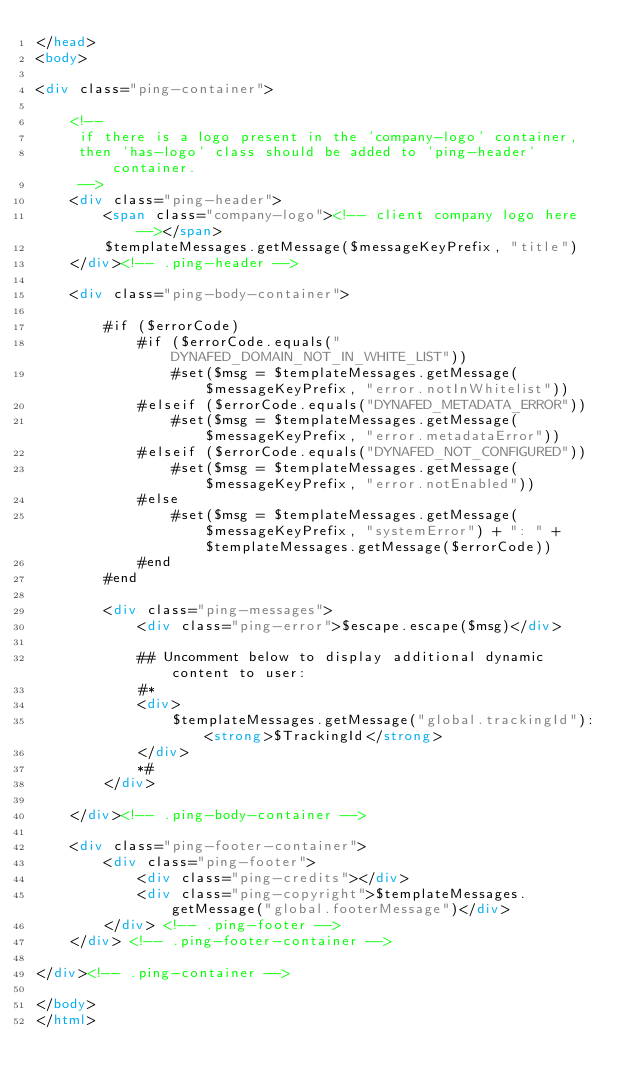Convert code to text. <code><loc_0><loc_0><loc_500><loc_500><_HTML_></head>
<body>
    
<div class="ping-container">
    
    <!-- 
     if there is a logo present in the 'company-logo' container,
     then 'has-logo' class should be added to 'ping-header' container.
     -->
    <div class="ping-header">
        <span class="company-logo"><!-- client company logo here --></span>
        $templateMessages.getMessage($messageKeyPrefix, "title")
    </div><!-- .ping-header -->
    
    <div class="ping-body-container">

        #if ($errorCode)
            #if ($errorCode.equals("DYNAFED_DOMAIN_NOT_IN_WHITE_LIST"))
                #set($msg = $templateMessages.getMessage($messageKeyPrefix, "error.notInWhitelist"))
            #elseif ($errorCode.equals("DYNAFED_METADATA_ERROR"))
                #set($msg = $templateMessages.getMessage($messageKeyPrefix, "error.metadataError"))
            #elseif ($errorCode.equals("DYNAFED_NOT_CONFIGURED"))
                #set($msg = $templateMessages.getMessage($messageKeyPrefix, "error.notEnabled"))
            #else
                #set($msg = $templateMessages.getMessage($messageKeyPrefix, "systemError") + ": " + $templateMessages.getMessage($errorCode))
            #end
        #end

        <div class="ping-messages">
            <div class="ping-error">$escape.escape($msg)</div>
    
            ## Uncomment below to display additional dynamic content to user:
            #*
            <div>
                $templateMessages.getMessage("global.trackingId"): <strong>$TrackingId</strong>
            </div>
            *#
        </div>

    </div><!-- .ping-body-container -->
    
    <div class="ping-footer-container">
        <div class="ping-footer">
            <div class="ping-credits"></div>
            <div class="ping-copyright">$templateMessages.getMessage("global.footerMessage")</div>
        </div> <!-- .ping-footer -->
    </div> <!-- .ping-footer-container -->
    
</div><!-- .ping-container -->

</body>
</html>
</code> 